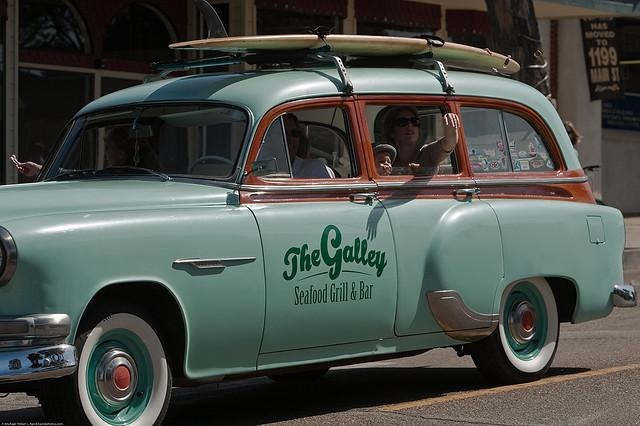Which one of these natural disasters might this car get caught in?

Choices:
A) blizzard
B) volcano
C) monsoon
D) earthquake earthquake 